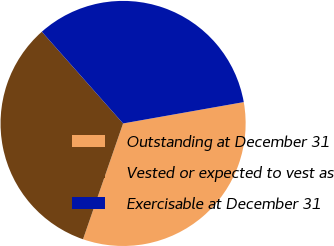Convert chart. <chart><loc_0><loc_0><loc_500><loc_500><pie_chart><fcel>Outstanding at December 31<fcel>Vested or expected to vest as<fcel>Exercisable at December 31<nl><fcel>33.09%<fcel>33.16%<fcel>33.75%<nl></chart> 